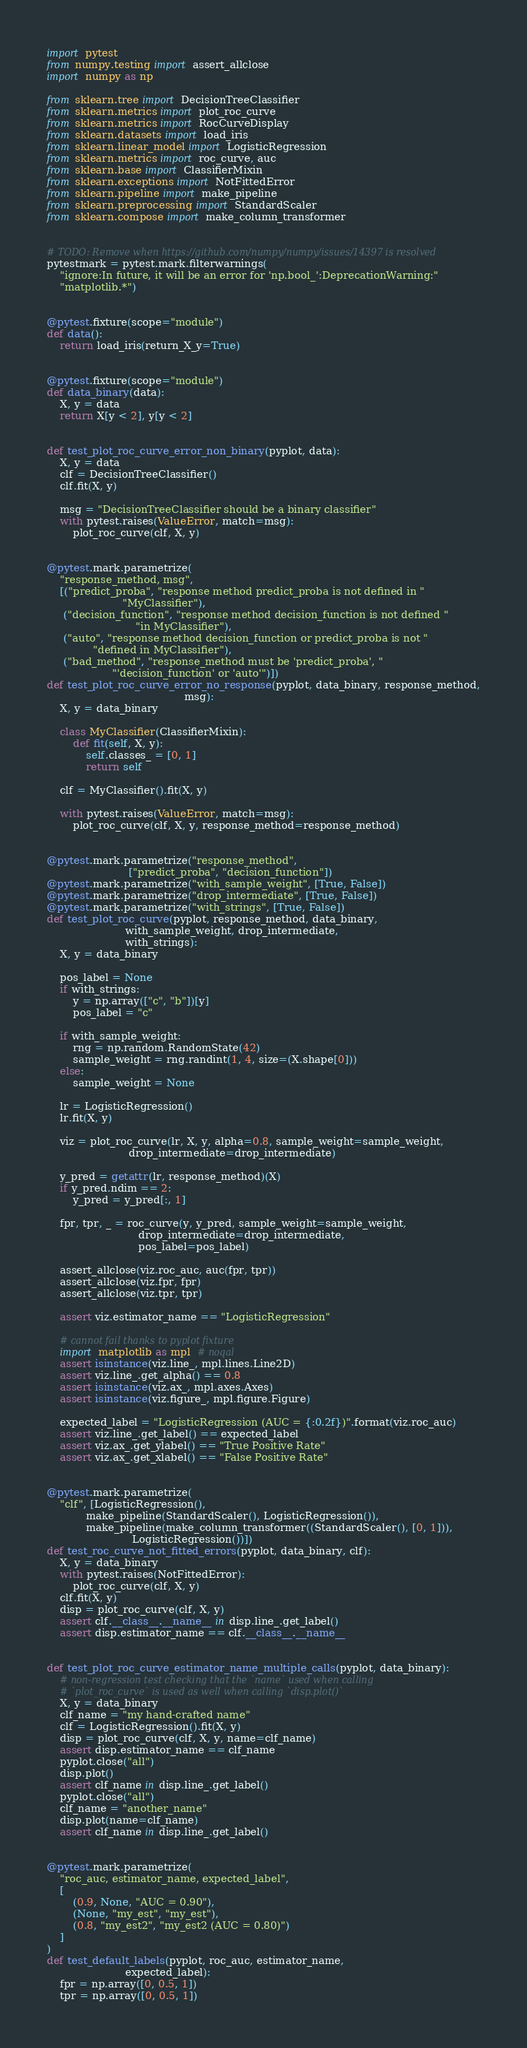<code> <loc_0><loc_0><loc_500><loc_500><_Python_>import pytest
from numpy.testing import assert_allclose
import numpy as np

from sklearn.tree import DecisionTreeClassifier
from sklearn.metrics import plot_roc_curve
from sklearn.metrics import RocCurveDisplay
from sklearn.datasets import load_iris
from sklearn.linear_model import LogisticRegression
from sklearn.metrics import roc_curve, auc
from sklearn.base import ClassifierMixin
from sklearn.exceptions import NotFittedError
from sklearn.pipeline import make_pipeline
from sklearn.preprocessing import StandardScaler
from sklearn.compose import make_column_transformer


# TODO: Remove when https://github.com/numpy/numpy/issues/14397 is resolved
pytestmark = pytest.mark.filterwarnings(
    "ignore:In future, it will be an error for 'np.bool_':DeprecationWarning:"
    "matplotlib.*")


@pytest.fixture(scope="module")
def data():
    return load_iris(return_X_y=True)


@pytest.fixture(scope="module")
def data_binary(data):
    X, y = data
    return X[y < 2], y[y < 2]


def test_plot_roc_curve_error_non_binary(pyplot, data):
    X, y = data
    clf = DecisionTreeClassifier()
    clf.fit(X, y)

    msg = "DecisionTreeClassifier should be a binary classifier"
    with pytest.raises(ValueError, match=msg):
        plot_roc_curve(clf, X, y)


@pytest.mark.parametrize(
    "response_method, msg",
    [("predict_proba", "response method predict_proba is not defined in "
                       "MyClassifier"),
     ("decision_function", "response method decision_function is not defined "
                           "in MyClassifier"),
     ("auto", "response method decision_function or predict_proba is not "
              "defined in MyClassifier"),
     ("bad_method", "response_method must be 'predict_proba', "
                    "'decision_function' or 'auto'")])
def test_plot_roc_curve_error_no_response(pyplot, data_binary, response_method,
                                          msg):
    X, y = data_binary

    class MyClassifier(ClassifierMixin):
        def fit(self, X, y):
            self.classes_ = [0, 1]
            return self

    clf = MyClassifier().fit(X, y)

    with pytest.raises(ValueError, match=msg):
        plot_roc_curve(clf, X, y, response_method=response_method)


@pytest.mark.parametrize("response_method",
                         ["predict_proba", "decision_function"])
@pytest.mark.parametrize("with_sample_weight", [True, False])
@pytest.mark.parametrize("drop_intermediate", [True, False])
@pytest.mark.parametrize("with_strings", [True, False])
def test_plot_roc_curve(pyplot, response_method, data_binary,
                        with_sample_weight, drop_intermediate,
                        with_strings):
    X, y = data_binary

    pos_label = None
    if with_strings:
        y = np.array(["c", "b"])[y]
        pos_label = "c"

    if with_sample_weight:
        rng = np.random.RandomState(42)
        sample_weight = rng.randint(1, 4, size=(X.shape[0]))
    else:
        sample_weight = None

    lr = LogisticRegression()
    lr.fit(X, y)

    viz = plot_roc_curve(lr, X, y, alpha=0.8, sample_weight=sample_weight,
                         drop_intermediate=drop_intermediate)

    y_pred = getattr(lr, response_method)(X)
    if y_pred.ndim == 2:
        y_pred = y_pred[:, 1]

    fpr, tpr, _ = roc_curve(y, y_pred, sample_weight=sample_weight,
                            drop_intermediate=drop_intermediate,
                            pos_label=pos_label)

    assert_allclose(viz.roc_auc, auc(fpr, tpr))
    assert_allclose(viz.fpr, fpr)
    assert_allclose(viz.tpr, tpr)

    assert viz.estimator_name == "LogisticRegression"

    # cannot fail thanks to pyplot fixture
    import matplotlib as mpl  # noqal
    assert isinstance(viz.line_, mpl.lines.Line2D)
    assert viz.line_.get_alpha() == 0.8
    assert isinstance(viz.ax_, mpl.axes.Axes)
    assert isinstance(viz.figure_, mpl.figure.Figure)

    expected_label = "LogisticRegression (AUC = {:0.2f})".format(viz.roc_auc)
    assert viz.line_.get_label() == expected_label
    assert viz.ax_.get_ylabel() == "True Positive Rate"
    assert viz.ax_.get_xlabel() == "False Positive Rate"


@pytest.mark.parametrize(
    "clf", [LogisticRegression(),
            make_pipeline(StandardScaler(), LogisticRegression()),
            make_pipeline(make_column_transformer((StandardScaler(), [0, 1])),
                          LogisticRegression())])
def test_roc_curve_not_fitted_errors(pyplot, data_binary, clf):
    X, y = data_binary
    with pytest.raises(NotFittedError):
        plot_roc_curve(clf, X, y)
    clf.fit(X, y)
    disp = plot_roc_curve(clf, X, y)
    assert clf.__class__.__name__ in disp.line_.get_label()
    assert disp.estimator_name == clf.__class__.__name__


def test_plot_roc_curve_estimator_name_multiple_calls(pyplot, data_binary):
    # non-regression test checking that the `name` used when calling
    # `plot_roc_curve` is used as well when calling `disp.plot()`
    X, y = data_binary
    clf_name = "my hand-crafted name"
    clf = LogisticRegression().fit(X, y)
    disp = plot_roc_curve(clf, X, y, name=clf_name)
    assert disp.estimator_name == clf_name
    pyplot.close("all")
    disp.plot()
    assert clf_name in disp.line_.get_label()
    pyplot.close("all")
    clf_name = "another_name"
    disp.plot(name=clf_name)
    assert clf_name in disp.line_.get_label()


@pytest.mark.parametrize(
    "roc_auc, estimator_name, expected_label",
    [
        (0.9, None, "AUC = 0.90"),
        (None, "my_est", "my_est"),
        (0.8, "my_est2", "my_est2 (AUC = 0.80)")
    ]
)
def test_default_labels(pyplot, roc_auc, estimator_name,
                        expected_label):
    fpr = np.array([0, 0.5, 1])
    tpr = np.array([0, 0.5, 1])</code> 